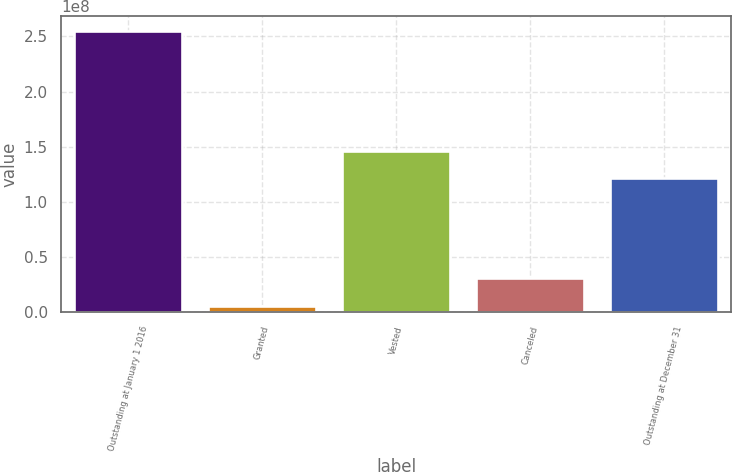Convert chart to OTSL. <chart><loc_0><loc_0><loc_500><loc_500><bar_chart><fcel>Outstanding at January 1 2016<fcel>Granted<fcel>Vested<fcel>Canceled<fcel>Outstanding at December 31<nl><fcel>2.55355e+08<fcel>5.78749e+06<fcel>1.46192e+08<fcel>3.07442e+07<fcel>1.21235e+08<nl></chart> 